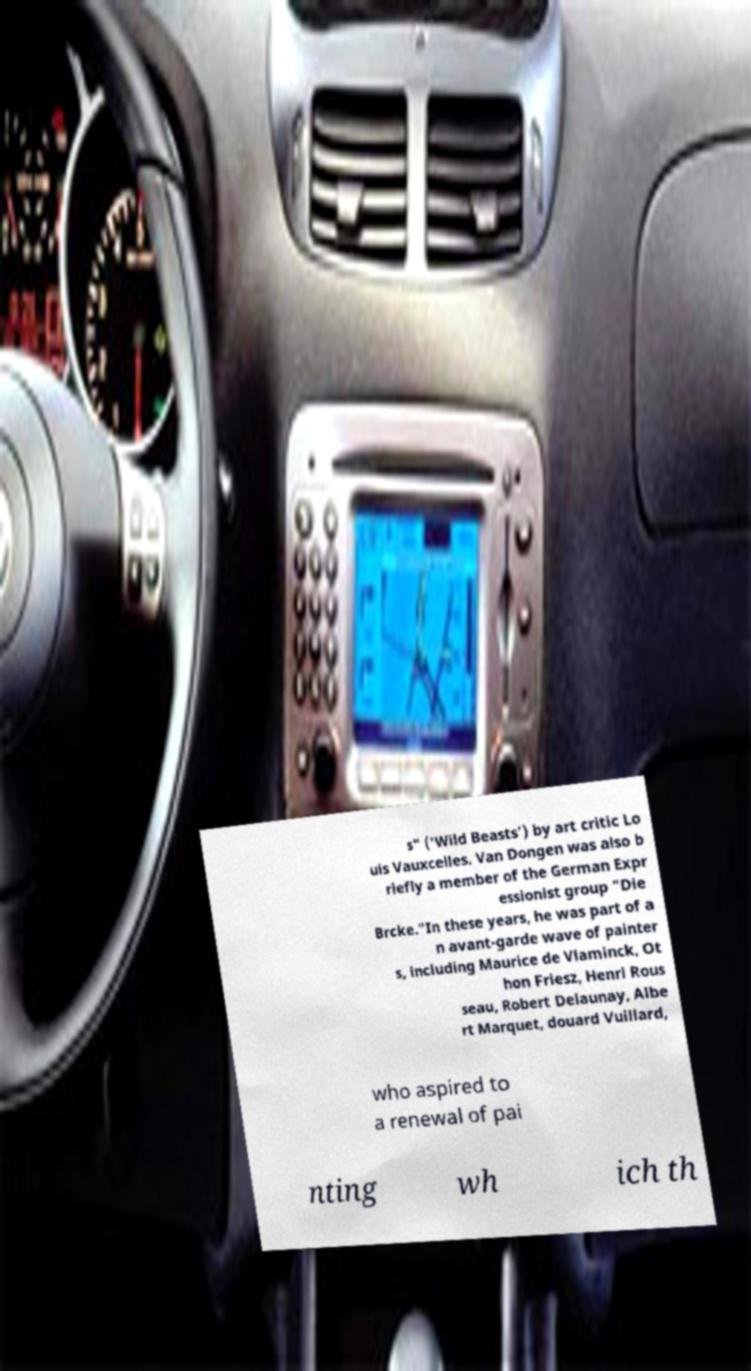Could you assist in decoding the text presented in this image and type it out clearly? s" ('Wild Beasts') by art critic Lo uis Vauxcelles. Van Dongen was also b riefly a member of the German Expr essionist group "Die Brcke."In these years, he was part of a n avant-garde wave of painter s, including Maurice de Vlaminck, Ot hon Friesz, Henri Rous seau, Robert Delaunay, Albe rt Marquet, douard Vuillard, who aspired to a renewal of pai nting wh ich th 